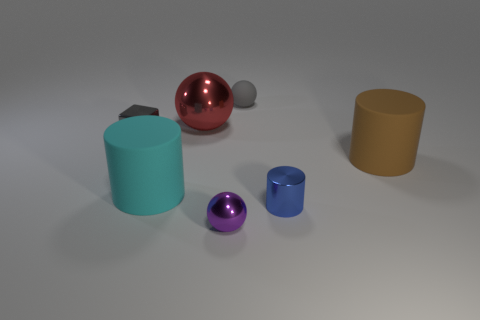Subtract all large metal balls. How many balls are left? 2 Subtract 1 spheres. How many spheres are left? 2 Add 2 large cyan matte cylinders. How many objects exist? 9 Subtract all blocks. How many objects are left? 6 Subtract all yellow balls. Subtract all red cylinders. How many balls are left? 3 Add 7 tiny purple blocks. How many tiny purple blocks exist? 7 Subtract 0 green blocks. How many objects are left? 7 Subtract all tiny metal balls. Subtract all matte cylinders. How many objects are left? 4 Add 1 purple metallic objects. How many purple metallic objects are left? 2 